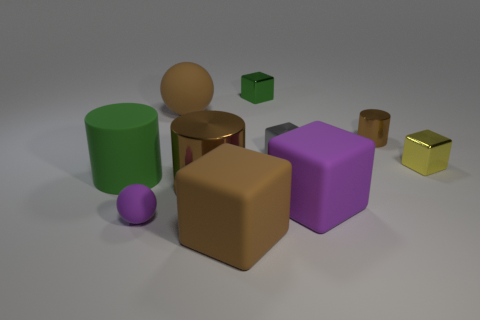How many balls have the same size as the yellow object?
Your answer should be very brief. 1. What size is the yellow object?
Offer a very short reply. Small. There is a gray object; what number of tiny metallic cubes are to the left of it?
Give a very brief answer. 1. What shape is the brown object that is made of the same material as the large brown cylinder?
Make the answer very short. Cylinder. Is the number of brown matte things that are on the left side of the gray metal cube less than the number of brown things on the right side of the big brown rubber ball?
Provide a succinct answer. Yes. Is the number of tiny balls greater than the number of large gray things?
Keep it short and to the point. Yes. What material is the brown cube?
Your response must be concise. Rubber. What is the color of the tiny cube that is on the left side of the small gray metallic object?
Your answer should be very brief. Green. Is the number of big brown things that are in front of the purple sphere greater than the number of large green rubber things in front of the large green cylinder?
Keep it short and to the point. Yes. There is a green object that is in front of the rubber object behind the big green rubber object that is behind the purple rubber sphere; what size is it?
Provide a short and direct response. Large. 